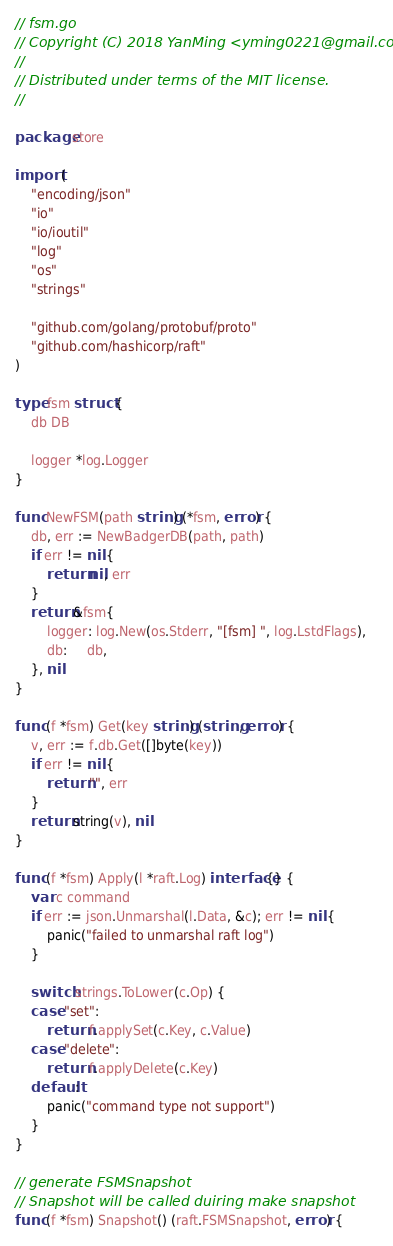Convert code to text. <code><loc_0><loc_0><loc_500><loc_500><_Go_>// fsm.go
// Copyright (C) 2018 YanMing <yming0221@gmail.com>
//
// Distributed under terms of the MIT license.
//

package store

import (
	"encoding/json"
	"io"
	"io/ioutil"
	"log"
	"os"
	"strings"

	"github.com/golang/protobuf/proto"
	"github.com/hashicorp/raft"
)

type fsm struct {
	db DB

	logger *log.Logger
}

func NewFSM(path string) (*fsm, error) {
	db, err := NewBadgerDB(path, path)
	if err != nil {
		return nil, err
	}
	return &fsm{
		logger: log.New(os.Stderr, "[fsm] ", log.LstdFlags),
		db:     db,
	}, nil
}

func (f *fsm) Get(key string) (string, error) {
	v, err := f.db.Get([]byte(key))
	if err != nil {
		return "", err
	}
	return string(v), nil
}

func (f *fsm) Apply(l *raft.Log) interface{} {
	var c command
	if err := json.Unmarshal(l.Data, &c); err != nil {
		panic("failed to unmarshal raft log")
	}

	switch strings.ToLower(c.Op) {
	case "set":
		return f.applySet(c.Key, c.Value)
	case "delete":
		return f.applyDelete(c.Key)
	default:
		panic("command type not support")
	}
}

// generate FSMSnapshot
// Snapshot will be called duiring make snapshot
func (f *fsm) Snapshot() (raft.FSMSnapshot, error) {</code> 